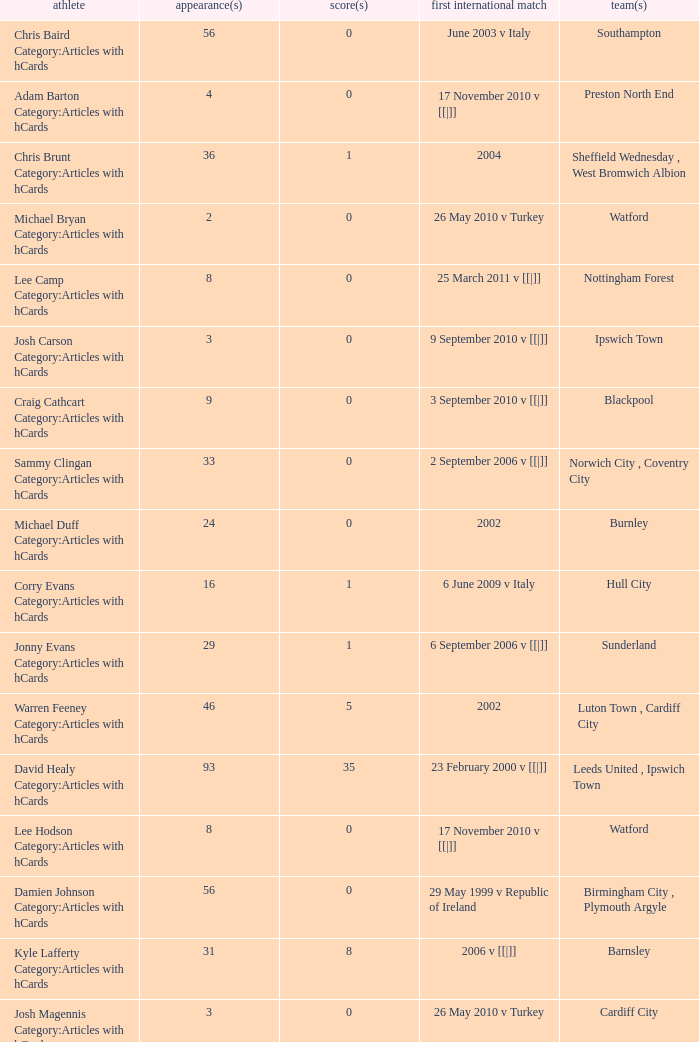How many caps figures for the Doncaster Rovers? 1.0. 